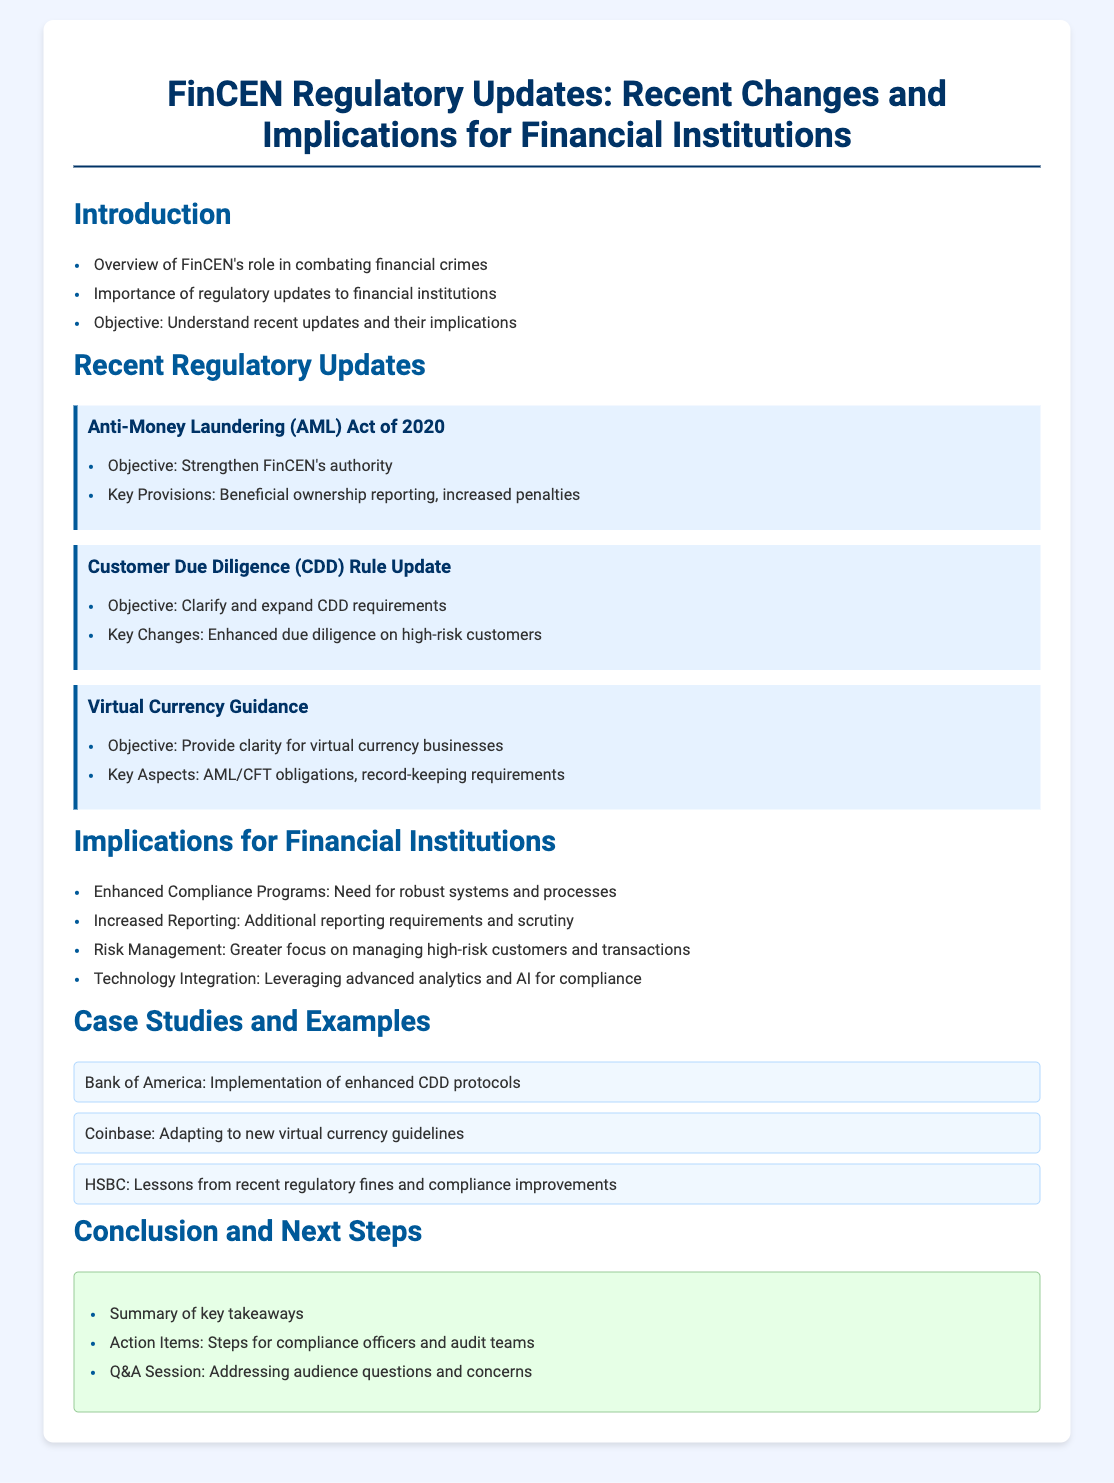what is the main objective of the Anti-Money Laundering Act of 2020? The main objective is to strengthen FinCEN's authority.
Answer: strengthen FinCEN's authority what are the key provisions of the Anti-Money Laundering Act of 2020? The document highlights beneficial ownership reporting and increased penalties as key provisions.
Answer: beneficial ownership reporting, increased penalties what change does the Customer Due Diligence Rule Update emphasize? It emphasizes enhanced due diligence on high-risk customers.
Answer: enhanced due diligence on high-risk customers what is one objective of the Virtual Currency Guidance? The objective is to provide clarity for virtual currency businesses.
Answer: provide clarity for virtual currency businesses what is one implication for financial institutions regarding compliance programs? Financial institutions need to have robust systems and processes.
Answer: robust systems and processes how are financial institutions expected to adapt their reporting? They face increased reporting requirements and scrutiny.
Answer: increased reporting requirements and scrutiny which bank implemented enhanced CDD protocols? Bank of America is mentioned as an example of this implementation.
Answer: Bank of America what has Coinbase adapted to? Coinbase has adapted to new virtual currency guidelines.
Answer: new virtual currency guidelines what is the color of the conclusion section in the presentation? The conclusion section is colored green.
Answer: green 